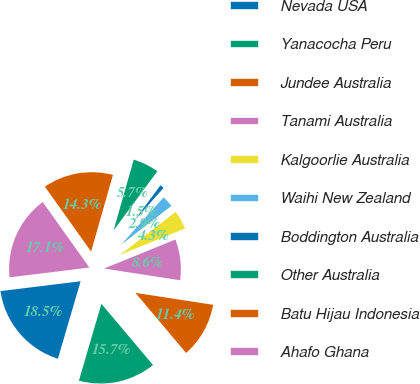<chart> <loc_0><loc_0><loc_500><loc_500><pie_chart><fcel>Nevada USA<fcel>Yanacocha Peru<fcel>Jundee Australia<fcel>Tanami Australia<fcel>Kalgoorlie Australia<fcel>Waihi New Zealand<fcel>Boddington Australia<fcel>Other Australia<fcel>Batu Hijau Indonesia<fcel>Ahafo Ghana<nl><fcel>18.52%<fcel>15.68%<fcel>11.42%<fcel>8.58%<fcel>4.32%<fcel>2.9%<fcel>1.48%<fcel>5.74%<fcel>14.26%<fcel>17.1%<nl></chart> 